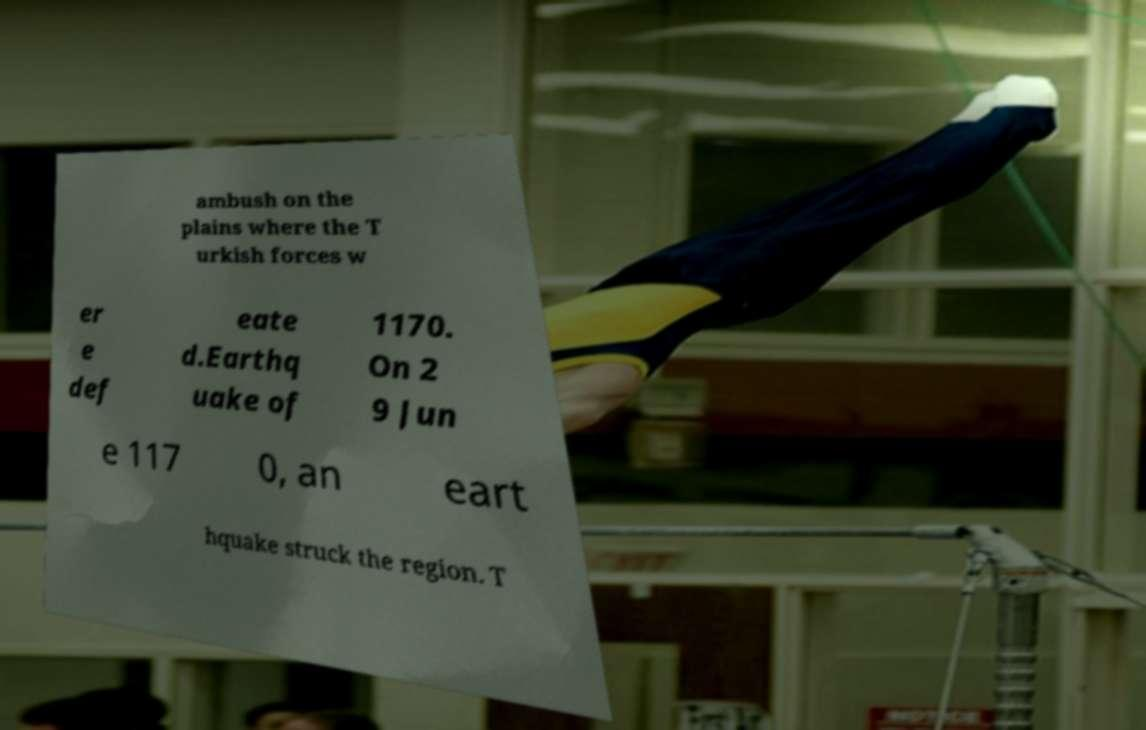Can you accurately transcribe the text from the provided image for me? ambush on the plains where the T urkish forces w er e def eate d.Earthq uake of 1170. On 2 9 Jun e 117 0, an eart hquake struck the region. T 